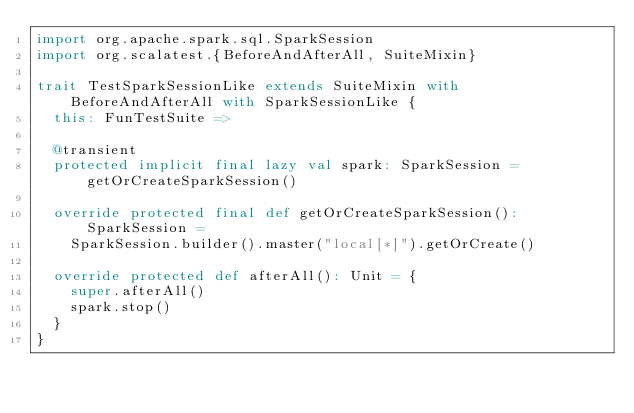Convert code to text. <code><loc_0><loc_0><loc_500><loc_500><_Scala_>import org.apache.spark.sql.SparkSession
import org.scalatest.{BeforeAndAfterAll, SuiteMixin}

trait TestSparkSessionLike extends SuiteMixin with BeforeAndAfterAll with SparkSessionLike {
  this: FunTestSuite =>

  @transient
  protected implicit final lazy val spark: SparkSession = getOrCreateSparkSession()

  override protected final def getOrCreateSparkSession(): SparkSession =
    SparkSession.builder().master("local[*]").getOrCreate()

  override protected def afterAll(): Unit = {
    super.afterAll()
    spark.stop()
  }
}
</code> 